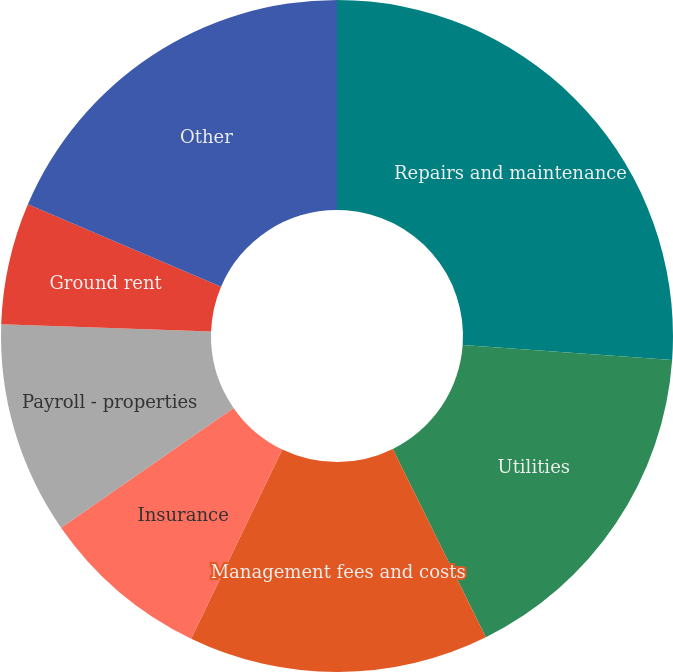<chart> <loc_0><loc_0><loc_500><loc_500><pie_chart><fcel>Repairs and maintenance<fcel>Utilities<fcel>Management fees and costs<fcel>Insurance<fcel>Payroll - properties<fcel>Ground rent<fcel>Other<nl><fcel>26.13%<fcel>16.56%<fcel>14.45%<fcel>8.19%<fcel>10.22%<fcel>5.85%<fcel>18.59%<nl></chart> 